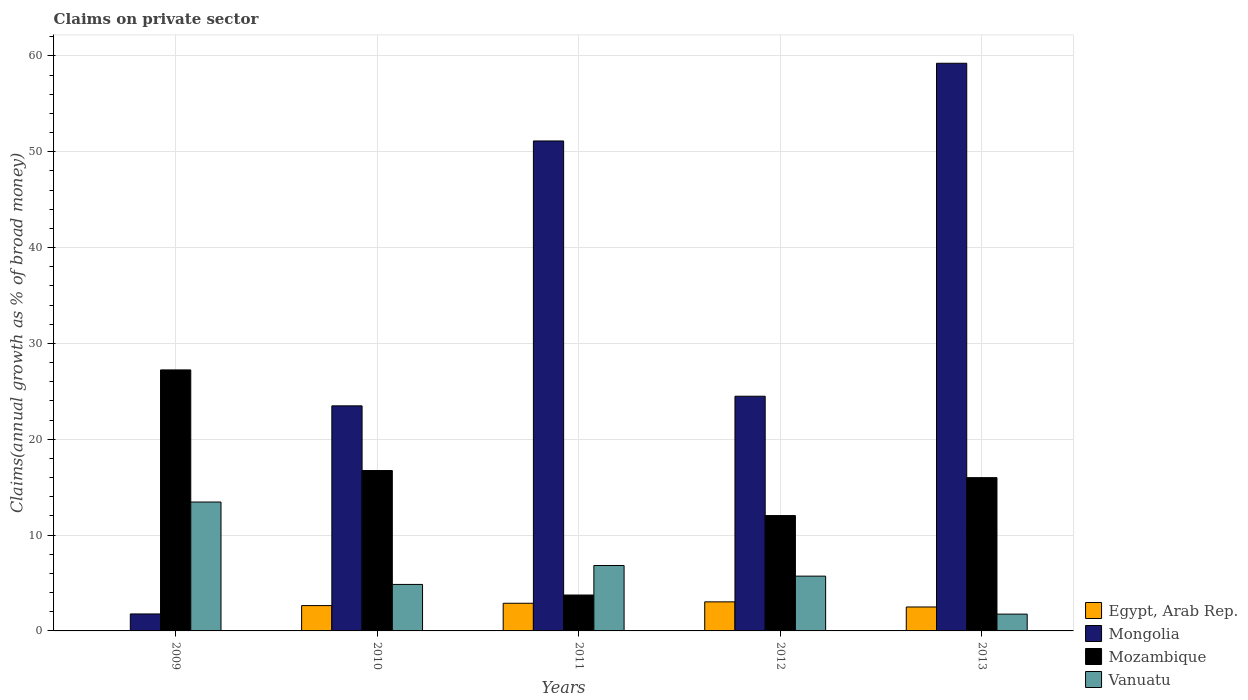Are the number of bars per tick equal to the number of legend labels?
Make the answer very short. No. How many bars are there on the 3rd tick from the left?
Offer a terse response. 4. How many bars are there on the 2nd tick from the right?
Offer a terse response. 4. What is the label of the 4th group of bars from the left?
Offer a very short reply. 2012. In how many cases, is the number of bars for a given year not equal to the number of legend labels?
Your response must be concise. 1. What is the percentage of broad money claimed on private sector in Egypt, Arab Rep. in 2009?
Provide a short and direct response. 0. Across all years, what is the maximum percentage of broad money claimed on private sector in Egypt, Arab Rep.?
Provide a short and direct response. 3.03. Across all years, what is the minimum percentage of broad money claimed on private sector in Vanuatu?
Make the answer very short. 1.75. In which year was the percentage of broad money claimed on private sector in Egypt, Arab Rep. maximum?
Keep it short and to the point. 2012. What is the total percentage of broad money claimed on private sector in Mozambique in the graph?
Offer a very short reply. 75.75. What is the difference between the percentage of broad money claimed on private sector in Vanuatu in 2010 and that in 2012?
Give a very brief answer. -0.87. What is the difference between the percentage of broad money claimed on private sector in Mongolia in 2010 and the percentage of broad money claimed on private sector in Egypt, Arab Rep. in 2013?
Offer a terse response. 20.99. What is the average percentage of broad money claimed on private sector in Mozambique per year?
Your answer should be compact. 15.15. In the year 2013, what is the difference between the percentage of broad money claimed on private sector in Egypt, Arab Rep. and percentage of broad money claimed on private sector in Mongolia?
Make the answer very short. -56.74. In how many years, is the percentage of broad money claimed on private sector in Mozambique greater than 14 %?
Keep it short and to the point. 3. What is the ratio of the percentage of broad money claimed on private sector in Vanuatu in 2010 to that in 2012?
Your answer should be very brief. 0.85. Is the percentage of broad money claimed on private sector in Vanuatu in 2009 less than that in 2012?
Ensure brevity in your answer.  No. What is the difference between the highest and the second highest percentage of broad money claimed on private sector in Mongolia?
Offer a terse response. 8.11. What is the difference between the highest and the lowest percentage of broad money claimed on private sector in Mongolia?
Keep it short and to the point. 57.47. Is it the case that in every year, the sum of the percentage of broad money claimed on private sector in Mozambique and percentage of broad money claimed on private sector in Egypt, Arab Rep. is greater than the sum of percentage of broad money claimed on private sector in Vanuatu and percentage of broad money claimed on private sector in Mongolia?
Your answer should be compact. No. Is it the case that in every year, the sum of the percentage of broad money claimed on private sector in Mongolia and percentage of broad money claimed on private sector in Vanuatu is greater than the percentage of broad money claimed on private sector in Egypt, Arab Rep.?
Your answer should be very brief. Yes. Does the graph contain any zero values?
Your answer should be compact. Yes. Does the graph contain grids?
Ensure brevity in your answer.  Yes. How are the legend labels stacked?
Give a very brief answer. Vertical. What is the title of the graph?
Provide a short and direct response. Claims on private sector. What is the label or title of the Y-axis?
Offer a terse response. Claims(annual growth as % of broad money). What is the Claims(annual growth as % of broad money) in Mongolia in 2009?
Offer a very short reply. 1.77. What is the Claims(annual growth as % of broad money) of Mozambique in 2009?
Provide a succinct answer. 27.24. What is the Claims(annual growth as % of broad money) of Vanuatu in 2009?
Make the answer very short. 13.45. What is the Claims(annual growth as % of broad money) of Egypt, Arab Rep. in 2010?
Your answer should be compact. 2.64. What is the Claims(annual growth as % of broad money) in Mongolia in 2010?
Ensure brevity in your answer.  23.49. What is the Claims(annual growth as % of broad money) in Mozambique in 2010?
Keep it short and to the point. 16.74. What is the Claims(annual growth as % of broad money) in Vanuatu in 2010?
Your answer should be very brief. 4.85. What is the Claims(annual growth as % of broad money) of Egypt, Arab Rep. in 2011?
Your answer should be very brief. 2.89. What is the Claims(annual growth as % of broad money) in Mongolia in 2011?
Keep it short and to the point. 51.13. What is the Claims(annual growth as % of broad money) of Mozambique in 2011?
Ensure brevity in your answer.  3.75. What is the Claims(annual growth as % of broad money) of Vanuatu in 2011?
Make the answer very short. 6.83. What is the Claims(annual growth as % of broad money) of Egypt, Arab Rep. in 2012?
Keep it short and to the point. 3.03. What is the Claims(annual growth as % of broad money) of Mongolia in 2012?
Make the answer very short. 24.49. What is the Claims(annual growth as % of broad money) in Mozambique in 2012?
Your answer should be compact. 12.04. What is the Claims(annual growth as % of broad money) of Vanuatu in 2012?
Your response must be concise. 5.72. What is the Claims(annual growth as % of broad money) in Egypt, Arab Rep. in 2013?
Offer a very short reply. 2.5. What is the Claims(annual growth as % of broad money) of Mongolia in 2013?
Ensure brevity in your answer.  59.24. What is the Claims(annual growth as % of broad money) of Mozambique in 2013?
Ensure brevity in your answer.  15.99. What is the Claims(annual growth as % of broad money) in Vanuatu in 2013?
Provide a short and direct response. 1.75. Across all years, what is the maximum Claims(annual growth as % of broad money) in Egypt, Arab Rep.?
Your answer should be compact. 3.03. Across all years, what is the maximum Claims(annual growth as % of broad money) of Mongolia?
Offer a terse response. 59.24. Across all years, what is the maximum Claims(annual growth as % of broad money) of Mozambique?
Ensure brevity in your answer.  27.24. Across all years, what is the maximum Claims(annual growth as % of broad money) of Vanuatu?
Your response must be concise. 13.45. Across all years, what is the minimum Claims(annual growth as % of broad money) of Mongolia?
Keep it short and to the point. 1.77. Across all years, what is the minimum Claims(annual growth as % of broad money) of Mozambique?
Your response must be concise. 3.75. Across all years, what is the minimum Claims(annual growth as % of broad money) in Vanuatu?
Your response must be concise. 1.75. What is the total Claims(annual growth as % of broad money) of Egypt, Arab Rep. in the graph?
Your answer should be very brief. 11.06. What is the total Claims(annual growth as % of broad money) of Mongolia in the graph?
Offer a very short reply. 160.12. What is the total Claims(annual growth as % of broad money) of Mozambique in the graph?
Keep it short and to the point. 75.75. What is the total Claims(annual growth as % of broad money) in Vanuatu in the graph?
Make the answer very short. 32.6. What is the difference between the Claims(annual growth as % of broad money) of Mongolia in 2009 and that in 2010?
Offer a terse response. -21.72. What is the difference between the Claims(annual growth as % of broad money) of Mozambique in 2009 and that in 2010?
Offer a terse response. 10.5. What is the difference between the Claims(annual growth as % of broad money) in Vanuatu in 2009 and that in 2010?
Offer a very short reply. 8.6. What is the difference between the Claims(annual growth as % of broad money) in Mongolia in 2009 and that in 2011?
Your response must be concise. -49.36. What is the difference between the Claims(annual growth as % of broad money) of Mozambique in 2009 and that in 2011?
Make the answer very short. 23.49. What is the difference between the Claims(annual growth as % of broad money) of Vanuatu in 2009 and that in 2011?
Your response must be concise. 6.62. What is the difference between the Claims(annual growth as % of broad money) of Mongolia in 2009 and that in 2012?
Your answer should be very brief. -22.72. What is the difference between the Claims(annual growth as % of broad money) in Mozambique in 2009 and that in 2012?
Offer a very short reply. 15.2. What is the difference between the Claims(annual growth as % of broad money) of Vanuatu in 2009 and that in 2012?
Make the answer very short. 7.73. What is the difference between the Claims(annual growth as % of broad money) in Mongolia in 2009 and that in 2013?
Your response must be concise. -57.47. What is the difference between the Claims(annual growth as % of broad money) in Mozambique in 2009 and that in 2013?
Offer a very short reply. 11.24. What is the difference between the Claims(annual growth as % of broad money) of Vanuatu in 2009 and that in 2013?
Make the answer very short. 11.7. What is the difference between the Claims(annual growth as % of broad money) of Egypt, Arab Rep. in 2010 and that in 2011?
Provide a short and direct response. -0.24. What is the difference between the Claims(annual growth as % of broad money) in Mongolia in 2010 and that in 2011?
Offer a very short reply. -27.64. What is the difference between the Claims(annual growth as % of broad money) in Mozambique in 2010 and that in 2011?
Keep it short and to the point. 12.99. What is the difference between the Claims(annual growth as % of broad money) of Vanuatu in 2010 and that in 2011?
Give a very brief answer. -1.97. What is the difference between the Claims(annual growth as % of broad money) in Egypt, Arab Rep. in 2010 and that in 2012?
Make the answer very short. -0.39. What is the difference between the Claims(annual growth as % of broad money) in Mongolia in 2010 and that in 2012?
Your response must be concise. -1. What is the difference between the Claims(annual growth as % of broad money) in Mozambique in 2010 and that in 2012?
Provide a succinct answer. 4.7. What is the difference between the Claims(annual growth as % of broad money) in Vanuatu in 2010 and that in 2012?
Make the answer very short. -0.87. What is the difference between the Claims(annual growth as % of broad money) of Egypt, Arab Rep. in 2010 and that in 2013?
Keep it short and to the point. 0.14. What is the difference between the Claims(annual growth as % of broad money) in Mongolia in 2010 and that in 2013?
Make the answer very short. -35.75. What is the difference between the Claims(annual growth as % of broad money) in Mozambique in 2010 and that in 2013?
Provide a short and direct response. 0.74. What is the difference between the Claims(annual growth as % of broad money) of Vanuatu in 2010 and that in 2013?
Your answer should be compact. 3.1. What is the difference between the Claims(annual growth as % of broad money) of Egypt, Arab Rep. in 2011 and that in 2012?
Your answer should be compact. -0.15. What is the difference between the Claims(annual growth as % of broad money) of Mongolia in 2011 and that in 2012?
Keep it short and to the point. 26.64. What is the difference between the Claims(annual growth as % of broad money) in Mozambique in 2011 and that in 2012?
Provide a short and direct response. -8.29. What is the difference between the Claims(annual growth as % of broad money) of Vanuatu in 2011 and that in 2012?
Give a very brief answer. 1.11. What is the difference between the Claims(annual growth as % of broad money) in Egypt, Arab Rep. in 2011 and that in 2013?
Your response must be concise. 0.39. What is the difference between the Claims(annual growth as % of broad money) of Mongolia in 2011 and that in 2013?
Your answer should be compact. -8.11. What is the difference between the Claims(annual growth as % of broad money) in Mozambique in 2011 and that in 2013?
Keep it short and to the point. -12.25. What is the difference between the Claims(annual growth as % of broad money) of Vanuatu in 2011 and that in 2013?
Your response must be concise. 5.07. What is the difference between the Claims(annual growth as % of broad money) in Egypt, Arab Rep. in 2012 and that in 2013?
Make the answer very short. 0.53. What is the difference between the Claims(annual growth as % of broad money) in Mongolia in 2012 and that in 2013?
Make the answer very short. -34.75. What is the difference between the Claims(annual growth as % of broad money) in Mozambique in 2012 and that in 2013?
Provide a short and direct response. -3.95. What is the difference between the Claims(annual growth as % of broad money) in Vanuatu in 2012 and that in 2013?
Give a very brief answer. 3.96. What is the difference between the Claims(annual growth as % of broad money) of Mongolia in 2009 and the Claims(annual growth as % of broad money) of Mozambique in 2010?
Your answer should be very brief. -14.96. What is the difference between the Claims(annual growth as % of broad money) of Mongolia in 2009 and the Claims(annual growth as % of broad money) of Vanuatu in 2010?
Ensure brevity in your answer.  -3.08. What is the difference between the Claims(annual growth as % of broad money) in Mozambique in 2009 and the Claims(annual growth as % of broad money) in Vanuatu in 2010?
Provide a short and direct response. 22.38. What is the difference between the Claims(annual growth as % of broad money) in Mongolia in 2009 and the Claims(annual growth as % of broad money) in Mozambique in 2011?
Your answer should be very brief. -1.97. What is the difference between the Claims(annual growth as % of broad money) of Mongolia in 2009 and the Claims(annual growth as % of broad money) of Vanuatu in 2011?
Your response must be concise. -5.05. What is the difference between the Claims(annual growth as % of broad money) of Mozambique in 2009 and the Claims(annual growth as % of broad money) of Vanuatu in 2011?
Provide a short and direct response. 20.41. What is the difference between the Claims(annual growth as % of broad money) in Mongolia in 2009 and the Claims(annual growth as % of broad money) in Mozambique in 2012?
Your answer should be very brief. -10.27. What is the difference between the Claims(annual growth as % of broad money) in Mongolia in 2009 and the Claims(annual growth as % of broad money) in Vanuatu in 2012?
Offer a terse response. -3.95. What is the difference between the Claims(annual growth as % of broad money) in Mozambique in 2009 and the Claims(annual growth as % of broad money) in Vanuatu in 2012?
Offer a very short reply. 21.52. What is the difference between the Claims(annual growth as % of broad money) of Mongolia in 2009 and the Claims(annual growth as % of broad money) of Mozambique in 2013?
Offer a very short reply. -14.22. What is the difference between the Claims(annual growth as % of broad money) of Mongolia in 2009 and the Claims(annual growth as % of broad money) of Vanuatu in 2013?
Ensure brevity in your answer.  0.02. What is the difference between the Claims(annual growth as % of broad money) of Mozambique in 2009 and the Claims(annual growth as % of broad money) of Vanuatu in 2013?
Give a very brief answer. 25.48. What is the difference between the Claims(annual growth as % of broad money) in Egypt, Arab Rep. in 2010 and the Claims(annual growth as % of broad money) in Mongolia in 2011?
Your answer should be very brief. -48.49. What is the difference between the Claims(annual growth as % of broad money) in Egypt, Arab Rep. in 2010 and the Claims(annual growth as % of broad money) in Mozambique in 2011?
Make the answer very short. -1.1. What is the difference between the Claims(annual growth as % of broad money) in Egypt, Arab Rep. in 2010 and the Claims(annual growth as % of broad money) in Vanuatu in 2011?
Your answer should be very brief. -4.18. What is the difference between the Claims(annual growth as % of broad money) in Mongolia in 2010 and the Claims(annual growth as % of broad money) in Mozambique in 2011?
Your answer should be compact. 19.74. What is the difference between the Claims(annual growth as % of broad money) in Mongolia in 2010 and the Claims(annual growth as % of broad money) in Vanuatu in 2011?
Your response must be concise. 16.66. What is the difference between the Claims(annual growth as % of broad money) in Mozambique in 2010 and the Claims(annual growth as % of broad money) in Vanuatu in 2011?
Give a very brief answer. 9.91. What is the difference between the Claims(annual growth as % of broad money) of Egypt, Arab Rep. in 2010 and the Claims(annual growth as % of broad money) of Mongolia in 2012?
Your answer should be very brief. -21.85. What is the difference between the Claims(annual growth as % of broad money) of Egypt, Arab Rep. in 2010 and the Claims(annual growth as % of broad money) of Mozambique in 2012?
Offer a terse response. -9.4. What is the difference between the Claims(annual growth as % of broad money) in Egypt, Arab Rep. in 2010 and the Claims(annual growth as % of broad money) in Vanuatu in 2012?
Offer a very short reply. -3.08. What is the difference between the Claims(annual growth as % of broad money) in Mongolia in 2010 and the Claims(annual growth as % of broad money) in Mozambique in 2012?
Offer a very short reply. 11.45. What is the difference between the Claims(annual growth as % of broad money) in Mongolia in 2010 and the Claims(annual growth as % of broad money) in Vanuatu in 2012?
Make the answer very short. 17.77. What is the difference between the Claims(annual growth as % of broad money) in Mozambique in 2010 and the Claims(annual growth as % of broad money) in Vanuatu in 2012?
Offer a terse response. 11.02. What is the difference between the Claims(annual growth as % of broad money) in Egypt, Arab Rep. in 2010 and the Claims(annual growth as % of broad money) in Mongolia in 2013?
Offer a terse response. -56.6. What is the difference between the Claims(annual growth as % of broad money) in Egypt, Arab Rep. in 2010 and the Claims(annual growth as % of broad money) in Mozambique in 2013?
Ensure brevity in your answer.  -13.35. What is the difference between the Claims(annual growth as % of broad money) in Egypt, Arab Rep. in 2010 and the Claims(annual growth as % of broad money) in Vanuatu in 2013?
Offer a very short reply. 0.89. What is the difference between the Claims(annual growth as % of broad money) of Mongolia in 2010 and the Claims(annual growth as % of broad money) of Mozambique in 2013?
Your response must be concise. 7.49. What is the difference between the Claims(annual growth as % of broad money) of Mongolia in 2010 and the Claims(annual growth as % of broad money) of Vanuatu in 2013?
Your answer should be compact. 21.73. What is the difference between the Claims(annual growth as % of broad money) in Mozambique in 2010 and the Claims(annual growth as % of broad money) in Vanuatu in 2013?
Give a very brief answer. 14.98. What is the difference between the Claims(annual growth as % of broad money) in Egypt, Arab Rep. in 2011 and the Claims(annual growth as % of broad money) in Mongolia in 2012?
Your answer should be compact. -21.6. What is the difference between the Claims(annual growth as % of broad money) in Egypt, Arab Rep. in 2011 and the Claims(annual growth as % of broad money) in Mozambique in 2012?
Provide a succinct answer. -9.15. What is the difference between the Claims(annual growth as % of broad money) of Egypt, Arab Rep. in 2011 and the Claims(annual growth as % of broad money) of Vanuatu in 2012?
Provide a short and direct response. -2.83. What is the difference between the Claims(annual growth as % of broad money) in Mongolia in 2011 and the Claims(annual growth as % of broad money) in Mozambique in 2012?
Offer a very short reply. 39.09. What is the difference between the Claims(annual growth as % of broad money) of Mongolia in 2011 and the Claims(annual growth as % of broad money) of Vanuatu in 2012?
Provide a succinct answer. 45.41. What is the difference between the Claims(annual growth as % of broad money) in Mozambique in 2011 and the Claims(annual growth as % of broad money) in Vanuatu in 2012?
Give a very brief answer. -1.97. What is the difference between the Claims(annual growth as % of broad money) of Egypt, Arab Rep. in 2011 and the Claims(annual growth as % of broad money) of Mongolia in 2013?
Give a very brief answer. -56.35. What is the difference between the Claims(annual growth as % of broad money) of Egypt, Arab Rep. in 2011 and the Claims(annual growth as % of broad money) of Mozambique in 2013?
Offer a very short reply. -13.11. What is the difference between the Claims(annual growth as % of broad money) of Egypt, Arab Rep. in 2011 and the Claims(annual growth as % of broad money) of Vanuatu in 2013?
Your response must be concise. 1.13. What is the difference between the Claims(annual growth as % of broad money) in Mongolia in 2011 and the Claims(annual growth as % of broad money) in Mozambique in 2013?
Offer a terse response. 35.13. What is the difference between the Claims(annual growth as % of broad money) in Mongolia in 2011 and the Claims(annual growth as % of broad money) in Vanuatu in 2013?
Make the answer very short. 49.37. What is the difference between the Claims(annual growth as % of broad money) in Mozambique in 2011 and the Claims(annual growth as % of broad money) in Vanuatu in 2013?
Your response must be concise. 1.99. What is the difference between the Claims(annual growth as % of broad money) in Egypt, Arab Rep. in 2012 and the Claims(annual growth as % of broad money) in Mongolia in 2013?
Your answer should be compact. -56.2. What is the difference between the Claims(annual growth as % of broad money) of Egypt, Arab Rep. in 2012 and the Claims(annual growth as % of broad money) of Mozambique in 2013?
Your answer should be compact. -12.96. What is the difference between the Claims(annual growth as % of broad money) in Egypt, Arab Rep. in 2012 and the Claims(annual growth as % of broad money) in Vanuatu in 2013?
Ensure brevity in your answer.  1.28. What is the difference between the Claims(annual growth as % of broad money) of Mongolia in 2012 and the Claims(annual growth as % of broad money) of Mozambique in 2013?
Provide a short and direct response. 8.5. What is the difference between the Claims(annual growth as % of broad money) in Mongolia in 2012 and the Claims(annual growth as % of broad money) in Vanuatu in 2013?
Keep it short and to the point. 22.74. What is the difference between the Claims(annual growth as % of broad money) of Mozambique in 2012 and the Claims(annual growth as % of broad money) of Vanuatu in 2013?
Ensure brevity in your answer.  10.29. What is the average Claims(annual growth as % of broad money) in Egypt, Arab Rep. per year?
Ensure brevity in your answer.  2.21. What is the average Claims(annual growth as % of broad money) of Mongolia per year?
Offer a terse response. 32.02. What is the average Claims(annual growth as % of broad money) in Mozambique per year?
Make the answer very short. 15.15. What is the average Claims(annual growth as % of broad money) in Vanuatu per year?
Make the answer very short. 6.52. In the year 2009, what is the difference between the Claims(annual growth as % of broad money) in Mongolia and Claims(annual growth as % of broad money) in Mozambique?
Offer a terse response. -25.47. In the year 2009, what is the difference between the Claims(annual growth as % of broad money) in Mongolia and Claims(annual growth as % of broad money) in Vanuatu?
Offer a very short reply. -11.68. In the year 2009, what is the difference between the Claims(annual growth as % of broad money) in Mozambique and Claims(annual growth as % of broad money) in Vanuatu?
Give a very brief answer. 13.79. In the year 2010, what is the difference between the Claims(annual growth as % of broad money) in Egypt, Arab Rep. and Claims(annual growth as % of broad money) in Mongolia?
Ensure brevity in your answer.  -20.84. In the year 2010, what is the difference between the Claims(annual growth as % of broad money) of Egypt, Arab Rep. and Claims(annual growth as % of broad money) of Mozambique?
Your answer should be very brief. -14.09. In the year 2010, what is the difference between the Claims(annual growth as % of broad money) of Egypt, Arab Rep. and Claims(annual growth as % of broad money) of Vanuatu?
Your answer should be very brief. -2.21. In the year 2010, what is the difference between the Claims(annual growth as % of broad money) of Mongolia and Claims(annual growth as % of broad money) of Mozambique?
Your answer should be very brief. 6.75. In the year 2010, what is the difference between the Claims(annual growth as % of broad money) of Mongolia and Claims(annual growth as % of broad money) of Vanuatu?
Offer a very short reply. 18.63. In the year 2010, what is the difference between the Claims(annual growth as % of broad money) in Mozambique and Claims(annual growth as % of broad money) in Vanuatu?
Provide a succinct answer. 11.88. In the year 2011, what is the difference between the Claims(annual growth as % of broad money) of Egypt, Arab Rep. and Claims(annual growth as % of broad money) of Mongolia?
Offer a very short reply. -48.24. In the year 2011, what is the difference between the Claims(annual growth as % of broad money) in Egypt, Arab Rep. and Claims(annual growth as % of broad money) in Mozambique?
Your response must be concise. -0.86. In the year 2011, what is the difference between the Claims(annual growth as % of broad money) of Egypt, Arab Rep. and Claims(annual growth as % of broad money) of Vanuatu?
Make the answer very short. -3.94. In the year 2011, what is the difference between the Claims(annual growth as % of broad money) in Mongolia and Claims(annual growth as % of broad money) in Mozambique?
Ensure brevity in your answer.  47.38. In the year 2011, what is the difference between the Claims(annual growth as % of broad money) of Mongolia and Claims(annual growth as % of broad money) of Vanuatu?
Provide a succinct answer. 44.3. In the year 2011, what is the difference between the Claims(annual growth as % of broad money) of Mozambique and Claims(annual growth as % of broad money) of Vanuatu?
Your answer should be compact. -3.08. In the year 2012, what is the difference between the Claims(annual growth as % of broad money) of Egypt, Arab Rep. and Claims(annual growth as % of broad money) of Mongolia?
Provide a short and direct response. -21.46. In the year 2012, what is the difference between the Claims(annual growth as % of broad money) of Egypt, Arab Rep. and Claims(annual growth as % of broad money) of Mozambique?
Make the answer very short. -9.01. In the year 2012, what is the difference between the Claims(annual growth as % of broad money) in Egypt, Arab Rep. and Claims(annual growth as % of broad money) in Vanuatu?
Provide a succinct answer. -2.68. In the year 2012, what is the difference between the Claims(annual growth as % of broad money) of Mongolia and Claims(annual growth as % of broad money) of Mozambique?
Offer a terse response. 12.45. In the year 2012, what is the difference between the Claims(annual growth as % of broad money) of Mongolia and Claims(annual growth as % of broad money) of Vanuatu?
Give a very brief answer. 18.77. In the year 2012, what is the difference between the Claims(annual growth as % of broad money) of Mozambique and Claims(annual growth as % of broad money) of Vanuatu?
Keep it short and to the point. 6.32. In the year 2013, what is the difference between the Claims(annual growth as % of broad money) of Egypt, Arab Rep. and Claims(annual growth as % of broad money) of Mongolia?
Provide a short and direct response. -56.74. In the year 2013, what is the difference between the Claims(annual growth as % of broad money) in Egypt, Arab Rep. and Claims(annual growth as % of broad money) in Mozambique?
Offer a very short reply. -13.5. In the year 2013, what is the difference between the Claims(annual growth as % of broad money) in Egypt, Arab Rep. and Claims(annual growth as % of broad money) in Vanuatu?
Make the answer very short. 0.74. In the year 2013, what is the difference between the Claims(annual growth as % of broad money) of Mongolia and Claims(annual growth as % of broad money) of Mozambique?
Ensure brevity in your answer.  43.24. In the year 2013, what is the difference between the Claims(annual growth as % of broad money) of Mongolia and Claims(annual growth as % of broad money) of Vanuatu?
Keep it short and to the point. 57.48. In the year 2013, what is the difference between the Claims(annual growth as % of broad money) of Mozambique and Claims(annual growth as % of broad money) of Vanuatu?
Offer a very short reply. 14.24. What is the ratio of the Claims(annual growth as % of broad money) in Mongolia in 2009 to that in 2010?
Provide a short and direct response. 0.08. What is the ratio of the Claims(annual growth as % of broad money) in Mozambique in 2009 to that in 2010?
Ensure brevity in your answer.  1.63. What is the ratio of the Claims(annual growth as % of broad money) of Vanuatu in 2009 to that in 2010?
Your answer should be very brief. 2.77. What is the ratio of the Claims(annual growth as % of broad money) of Mongolia in 2009 to that in 2011?
Keep it short and to the point. 0.03. What is the ratio of the Claims(annual growth as % of broad money) in Mozambique in 2009 to that in 2011?
Provide a short and direct response. 7.27. What is the ratio of the Claims(annual growth as % of broad money) in Vanuatu in 2009 to that in 2011?
Keep it short and to the point. 1.97. What is the ratio of the Claims(annual growth as % of broad money) in Mongolia in 2009 to that in 2012?
Provide a succinct answer. 0.07. What is the ratio of the Claims(annual growth as % of broad money) in Mozambique in 2009 to that in 2012?
Make the answer very short. 2.26. What is the ratio of the Claims(annual growth as % of broad money) of Vanuatu in 2009 to that in 2012?
Offer a very short reply. 2.35. What is the ratio of the Claims(annual growth as % of broad money) in Mongolia in 2009 to that in 2013?
Provide a succinct answer. 0.03. What is the ratio of the Claims(annual growth as % of broad money) in Mozambique in 2009 to that in 2013?
Your response must be concise. 1.7. What is the ratio of the Claims(annual growth as % of broad money) of Vanuatu in 2009 to that in 2013?
Offer a terse response. 7.67. What is the ratio of the Claims(annual growth as % of broad money) of Egypt, Arab Rep. in 2010 to that in 2011?
Provide a succinct answer. 0.92. What is the ratio of the Claims(annual growth as % of broad money) in Mongolia in 2010 to that in 2011?
Provide a short and direct response. 0.46. What is the ratio of the Claims(annual growth as % of broad money) of Mozambique in 2010 to that in 2011?
Your answer should be very brief. 4.47. What is the ratio of the Claims(annual growth as % of broad money) in Vanuatu in 2010 to that in 2011?
Offer a terse response. 0.71. What is the ratio of the Claims(annual growth as % of broad money) of Egypt, Arab Rep. in 2010 to that in 2012?
Your answer should be very brief. 0.87. What is the ratio of the Claims(annual growth as % of broad money) of Mozambique in 2010 to that in 2012?
Ensure brevity in your answer.  1.39. What is the ratio of the Claims(annual growth as % of broad money) in Vanuatu in 2010 to that in 2012?
Provide a succinct answer. 0.85. What is the ratio of the Claims(annual growth as % of broad money) in Egypt, Arab Rep. in 2010 to that in 2013?
Make the answer very short. 1.06. What is the ratio of the Claims(annual growth as % of broad money) of Mongolia in 2010 to that in 2013?
Your response must be concise. 0.4. What is the ratio of the Claims(annual growth as % of broad money) of Mozambique in 2010 to that in 2013?
Your answer should be compact. 1.05. What is the ratio of the Claims(annual growth as % of broad money) of Vanuatu in 2010 to that in 2013?
Your answer should be very brief. 2.77. What is the ratio of the Claims(annual growth as % of broad money) of Egypt, Arab Rep. in 2011 to that in 2012?
Offer a terse response. 0.95. What is the ratio of the Claims(annual growth as % of broad money) of Mongolia in 2011 to that in 2012?
Offer a very short reply. 2.09. What is the ratio of the Claims(annual growth as % of broad money) in Mozambique in 2011 to that in 2012?
Ensure brevity in your answer.  0.31. What is the ratio of the Claims(annual growth as % of broad money) in Vanuatu in 2011 to that in 2012?
Offer a terse response. 1.19. What is the ratio of the Claims(annual growth as % of broad money) in Egypt, Arab Rep. in 2011 to that in 2013?
Provide a succinct answer. 1.16. What is the ratio of the Claims(annual growth as % of broad money) of Mongolia in 2011 to that in 2013?
Your answer should be very brief. 0.86. What is the ratio of the Claims(annual growth as % of broad money) of Mozambique in 2011 to that in 2013?
Provide a succinct answer. 0.23. What is the ratio of the Claims(annual growth as % of broad money) in Vanuatu in 2011 to that in 2013?
Your answer should be compact. 3.89. What is the ratio of the Claims(annual growth as % of broad money) of Egypt, Arab Rep. in 2012 to that in 2013?
Ensure brevity in your answer.  1.21. What is the ratio of the Claims(annual growth as % of broad money) of Mongolia in 2012 to that in 2013?
Provide a succinct answer. 0.41. What is the ratio of the Claims(annual growth as % of broad money) of Mozambique in 2012 to that in 2013?
Your answer should be very brief. 0.75. What is the ratio of the Claims(annual growth as % of broad money) of Vanuatu in 2012 to that in 2013?
Offer a terse response. 3.26. What is the difference between the highest and the second highest Claims(annual growth as % of broad money) in Egypt, Arab Rep.?
Offer a very short reply. 0.15. What is the difference between the highest and the second highest Claims(annual growth as % of broad money) of Mongolia?
Give a very brief answer. 8.11. What is the difference between the highest and the second highest Claims(annual growth as % of broad money) of Mozambique?
Your answer should be very brief. 10.5. What is the difference between the highest and the second highest Claims(annual growth as % of broad money) in Vanuatu?
Ensure brevity in your answer.  6.62. What is the difference between the highest and the lowest Claims(annual growth as % of broad money) of Egypt, Arab Rep.?
Offer a very short reply. 3.03. What is the difference between the highest and the lowest Claims(annual growth as % of broad money) in Mongolia?
Provide a short and direct response. 57.47. What is the difference between the highest and the lowest Claims(annual growth as % of broad money) in Mozambique?
Offer a terse response. 23.49. What is the difference between the highest and the lowest Claims(annual growth as % of broad money) of Vanuatu?
Your answer should be very brief. 11.7. 